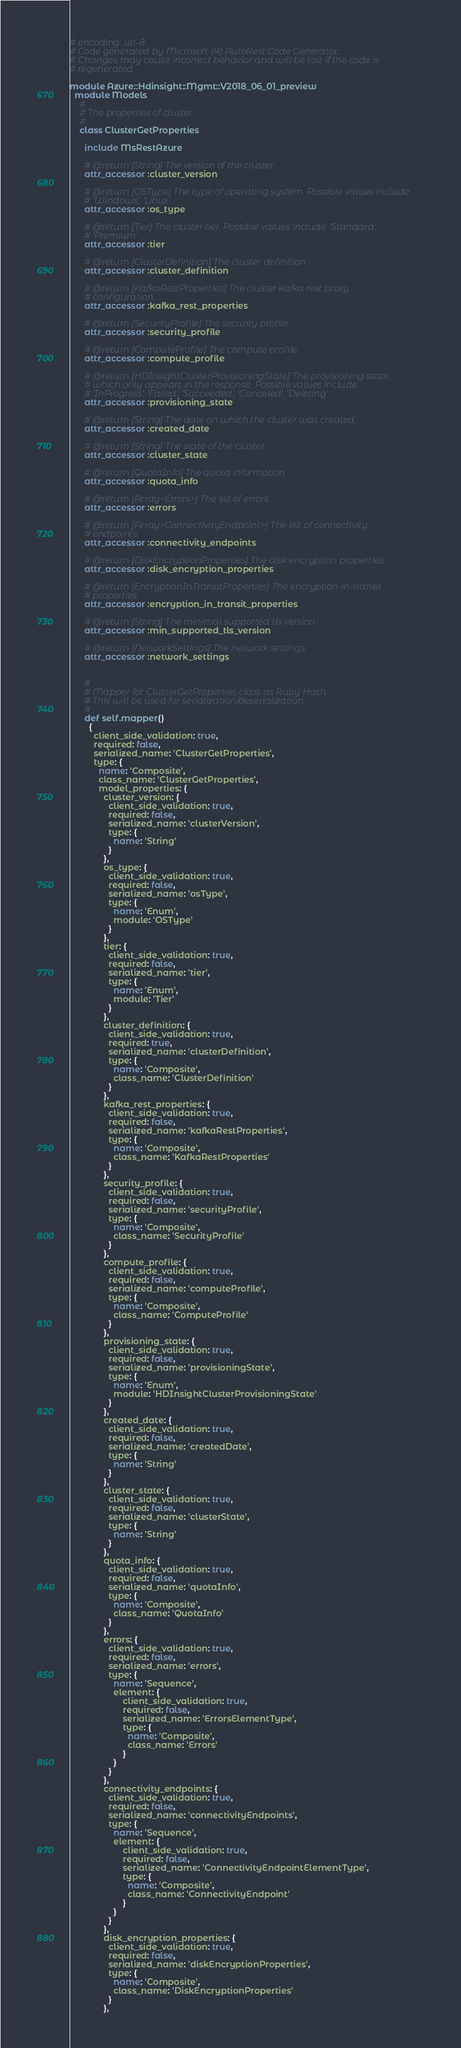Convert code to text. <code><loc_0><loc_0><loc_500><loc_500><_Ruby_># encoding: utf-8
# Code generated by Microsoft (R) AutoRest Code Generator.
# Changes may cause incorrect behavior and will be lost if the code is
# regenerated.

module Azure::Hdinsight::Mgmt::V2018_06_01_preview
  module Models
    #
    # The properties of cluster.
    #
    class ClusterGetProperties

      include MsRestAzure

      # @return [String] The version of the cluster.
      attr_accessor :cluster_version

      # @return [OSType] The type of operating system. Possible values include:
      # 'Windows', 'Linux'
      attr_accessor :os_type

      # @return [Tier] The cluster tier. Possible values include: 'Standard',
      # 'Premium'
      attr_accessor :tier

      # @return [ClusterDefinition] The cluster definition.
      attr_accessor :cluster_definition

      # @return [KafkaRestProperties] The cluster kafka rest proxy
      # configuration.
      attr_accessor :kafka_rest_properties

      # @return [SecurityProfile] The security profile.
      attr_accessor :security_profile

      # @return [ComputeProfile] The compute profile.
      attr_accessor :compute_profile

      # @return [HDInsightClusterProvisioningState] The provisioning state,
      # which only appears in the response. Possible values include:
      # 'InProgress', 'Failed', 'Succeeded', 'Canceled', 'Deleting'
      attr_accessor :provisioning_state

      # @return [String] The date on which the cluster was created.
      attr_accessor :created_date

      # @return [String] The state of the cluster.
      attr_accessor :cluster_state

      # @return [QuotaInfo] The quota information.
      attr_accessor :quota_info

      # @return [Array<Errors>] The list of errors.
      attr_accessor :errors

      # @return [Array<ConnectivityEndpoint>] The list of connectivity
      # endpoints.
      attr_accessor :connectivity_endpoints

      # @return [DiskEncryptionProperties] The disk encryption properties.
      attr_accessor :disk_encryption_properties

      # @return [EncryptionInTransitProperties] The encryption-in-transit
      # properties.
      attr_accessor :encryption_in_transit_properties

      # @return [String] The minimal supported tls version.
      attr_accessor :min_supported_tls_version

      # @return [NetworkSettings] The network settings.
      attr_accessor :network_settings


      #
      # Mapper for ClusterGetProperties class as Ruby Hash.
      # This will be used for serialization/deserialization.
      #
      def self.mapper()
        {
          client_side_validation: true,
          required: false,
          serialized_name: 'ClusterGetProperties',
          type: {
            name: 'Composite',
            class_name: 'ClusterGetProperties',
            model_properties: {
              cluster_version: {
                client_side_validation: true,
                required: false,
                serialized_name: 'clusterVersion',
                type: {
                  name: 'String'
                }
              },
              os_type: {
                client_side_validation: true,
                required: false,
                serialized_name: 'osType',
                type: {
                  name: 'Enum',
                  module: 'OSType'
                }
              },
              tier: {
                client_side_validation: true,
                required: false,
                serialized_name: 'tier',
                type: {
                  name: 'Enum',
                  module: 'Tier'
                }
              },
              cluster_definition: {
                client_side_validation: true,
                required: true,
                serialized_name: 'clusterDefinition',
                type: {
                  name: 'Composite',
                  class_name: 'ClusterDefinition'
                }
              },
              kafka_rest_properties: {
                client_side_validation: true,
                required: false,
                serialized_name: 'kafkaRestProperties',
                type: {
                  name: 'Composite',
                  class_name: 'KafkaRestProperties'
                }
              },
              security_profile: {
                client_side_validation: true,
                required: false,
                serialized_name: 'securityProfile',
                type: {
                  name: 'Composite',
                  class_name: 'SecurityProfile'
                }
              },
              compute_profile: {
                client_side_validation: true,
                required: false,
                serialized_name: 'computeProfile',
                type: {
                  name: 'Composite',
                  class_name: 'ComputeProfile'
                }
              },
              provisioning_state: {
                client_side_validation: true,
                required: false,
                serialized_name: 'provisioningState',
                type: {
                  name: 'Enum',
                  module: 'HDInsightClusterProvisioningState'
                }
              },
              created_date: {
                client_side_validation: true,
                required: false,
                serialized_name: 'createdDate',
                type: {
                  name: 'String'
                }
              },
              cluster_state: {
                client_side_validation: true,
                required: false,
                serialized_name: 'clusterState',
                type: {
                  name: 'String'
                }
              },
              quota_info: {
                client_side_validation: true,
                required: false,
                serialized_name: 'quotaInfo',
                type: {
                  name: 'Composite',
                  class_name: 'QuotaInfo'
                }
              },
              errors: {
                client_side_validation: true,
                required: false,
                serialized_name: 'errors',
                type: {
                  name: 'Sequence',
                  element: {
                      client_side_validation: true,
                      required: false,
                      serialized_name: 'ErrorsElementType',
                      type: {
                        name: 'Composite',
                        class_name: 'Errors'
                      }
                  }
                }
              },
              connectivity_endpoints: {
                client_side_validation: true,
                required: false,
                serialized_name: 'connectivityEndpoints',
                type: {
                  name: 'Sequence',
                  element: {
                      client_side_validation: true,
                      required: false,
                      serialized_name: 'ConnectivityEndpointElementType',
                      type: {
                        name: 'Composite',
                        class_name: 'ConnectivityEndpoint'
                      }
                  }
                }
              },
              disk_encryption_properties: {
                client_side_validation: true,
                required: false,
                serialized_name: 'diskEncryptionProperties',
                type: {
                  name: 'Composite',
                  class_name: 'DiskEncryptionProperties'
                }
              },</code> 